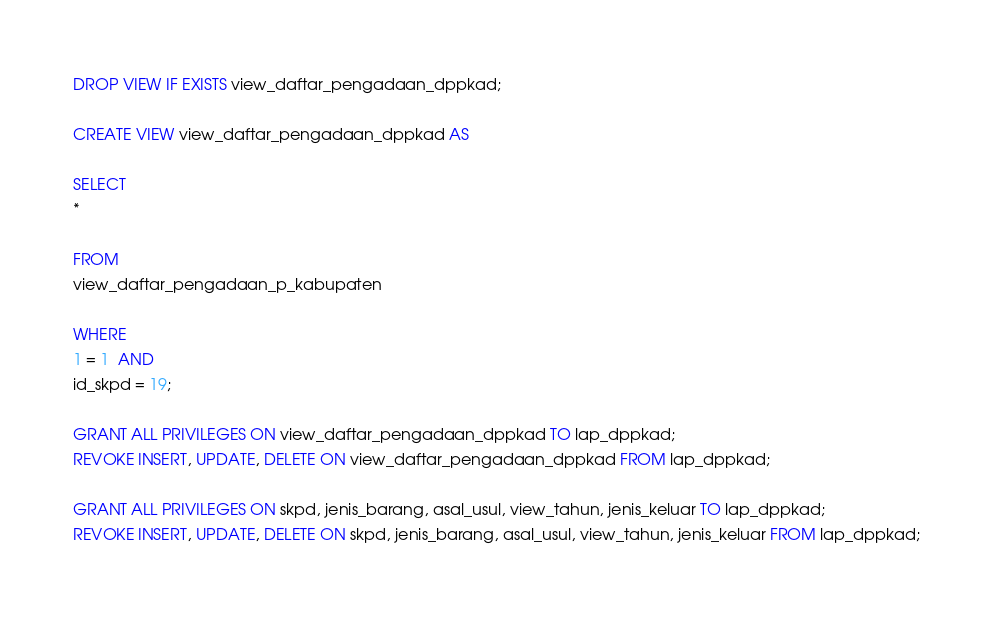Convert code to text. <code><loc_0><loc_0><loc_500><loc_500><_SQL_>DROP VIEW IF EXISTS view_daftar_pengadaan_dppkad;

CREATE VIEW view_daftar_pengadaan_dppkad AS

SELECT
*

FROM
view_daftar_pengadaan_p_kabupaten

WHERE
1 = 1  AND
id_skpd = 19;

GRANT ALL PRIVILEGES ON view_daftar_pengadaan_dppkad TO lap_dppkad;
REVOKE INSERT, UPDATE, DELETE ON view_daftar_pengadaan_dppkad FROM lap_dppkad;

GRANT ALL PRIVILEGES ON skpd, jenis_barang, asal_usul, view_tahun, jenis_keluar TO lap_dppkad;
REVOKE INSERT, UPDATE, DELETE ON skpd, jenis_barang, asal_usul, view_tahun, jenis_keluar FROM lap_dppkad;
</code> 